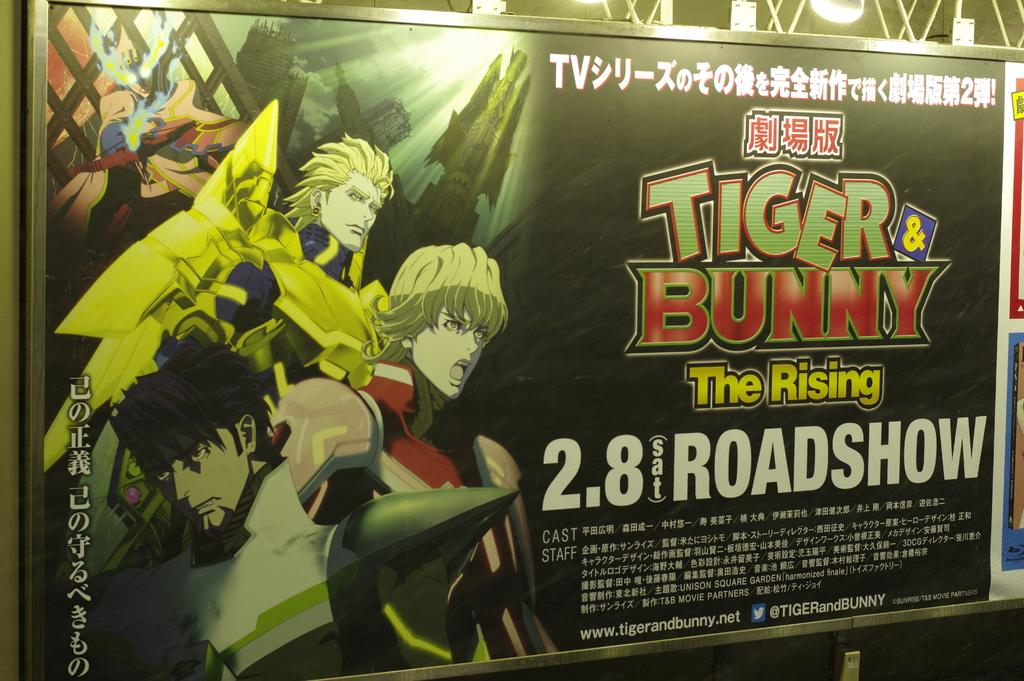<image>
Share a concise interpretation of the image provided. An ad for Tiger and Bunny, The Rising, at the Roadshow on 2.8. 